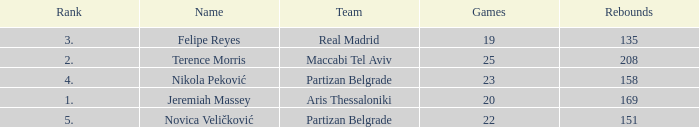How many Rebounds did Novica Veličković get in less than 22 Games? None. 